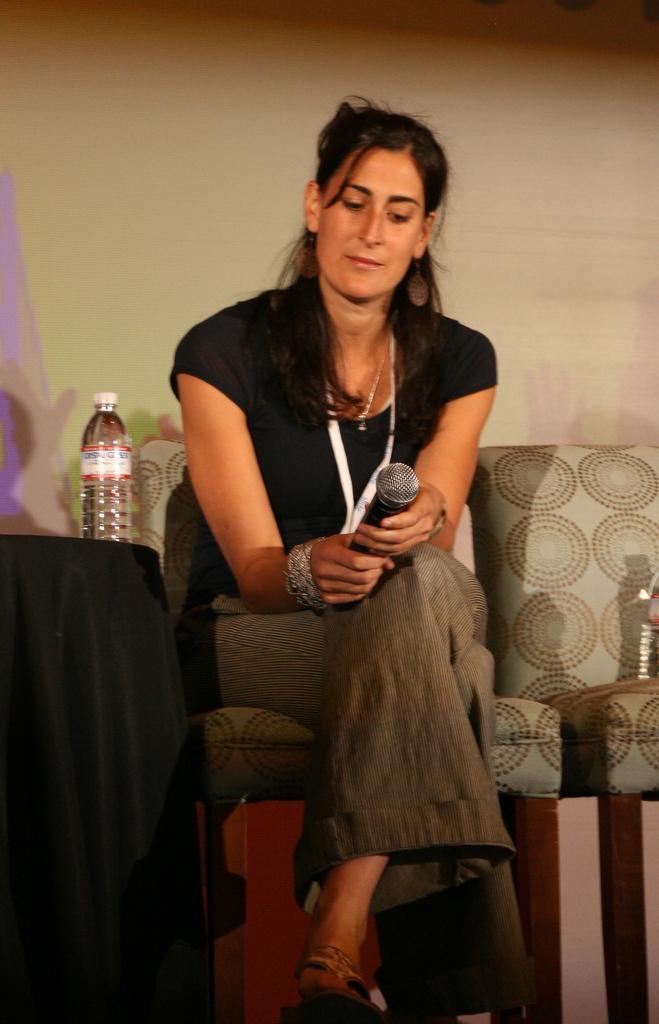Please provide a concise description of this image. In this picture we can see a woman who is sitting on the chair. She is holding a mike with her hand. On the background there is a wall. And this is the bottle. 